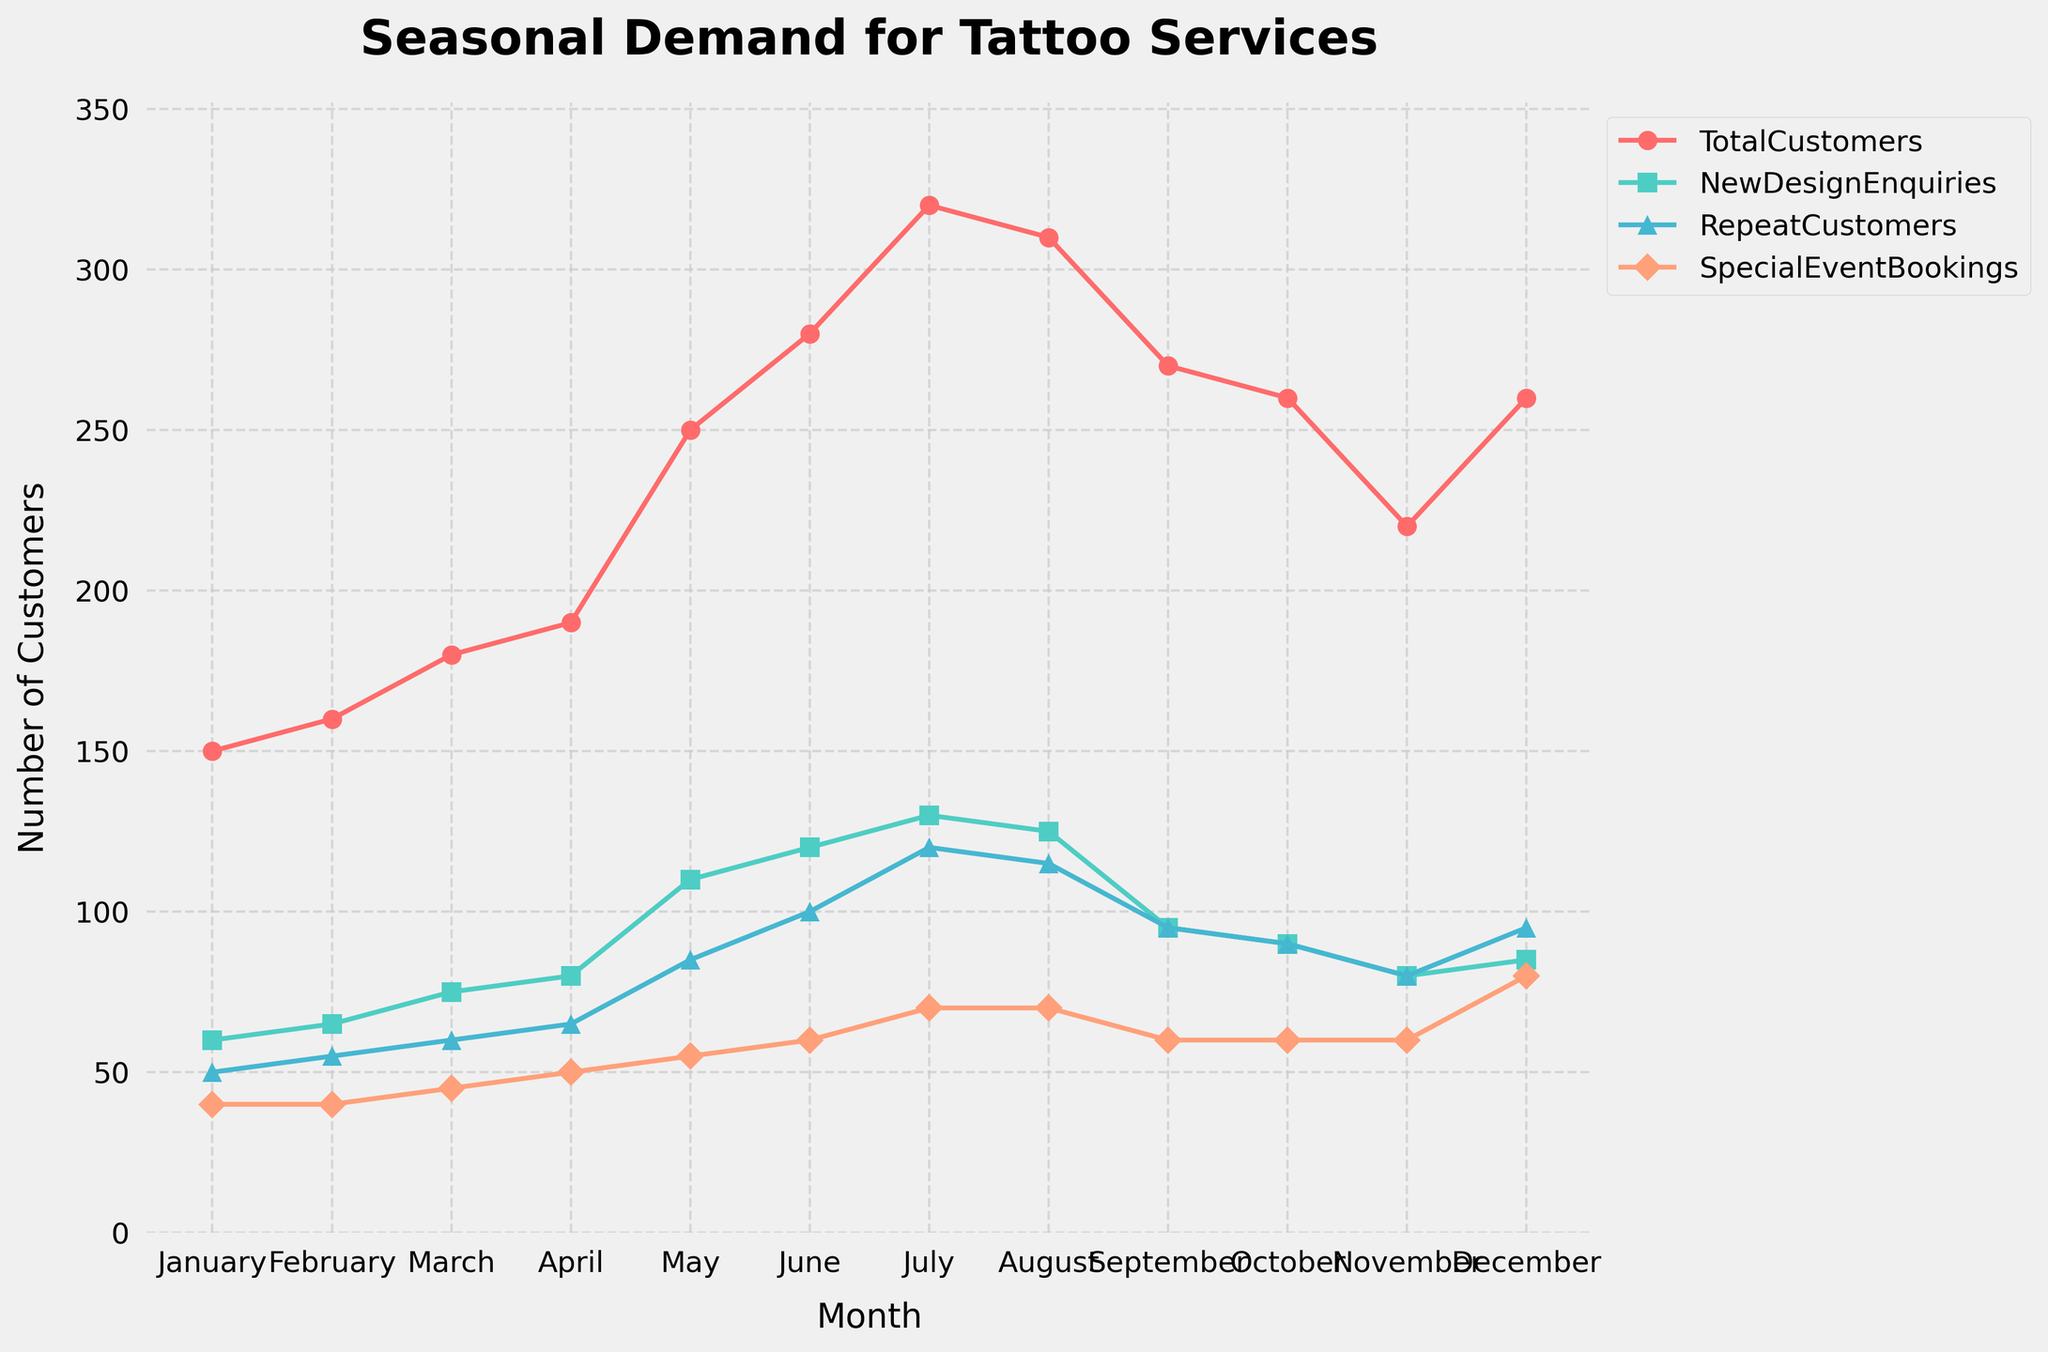What's the title of the chart? The title is displayed prominently at the top of the chart. It reads 'Seasonal Demand for Tattoo Services'.
Answer: Seasonal Demand for Tattoo Services Which metric has the highest value in July? By observing the chart, the line representing 'TotalCustomers' reaches the highest peak in July, above 300. This indicates 'TotalCustomers' has the highest value in July.
Answer: TotalCustomers Compare 'TotalCustomers' and 'SpecialEventBookings' in December. Which one is greater and by how much? In December, 'TotalCustomers' is around 260, while 'SpecialEventBookings' is around 80. The difference between them is 260 - 80.
Answer: TotalCustomers by 180 In which month did 'NewDesignEnquiries' reach its peak? By examining the chart, 'NewDesignEnquiries' is highest in July, indicated by the largest marker.
Answer: July Calculate the average number of 'RepeatCustomers' over the entire year. Adding all 'RepeatCustomers' values: 50+55+60+65+85+100+120+115+95+90+80+95 = 1020. Dividing by 12 months gives 1020 / 12.
Answer: 85 How does the number of 'TotalCustomers' change from May to June? The chart shows 'TotalCustomers' increasing from May (250) to June (280). The difference is 280 - 250.
Answer: Increases by 30 Which month shows the highest 'SpecialEventBookings', and what is the value? According to the chart, December shows the highest 'SpecialEventBookings' at a value of 80, represented by the highest peak for that metric.
Answer: December, 80 Is there a month where 'NewDesignEnquiries' and 'RepeatCustomers' have the same value? By comparing the lines for 'NewDesignEnquiries' and 'RepeatCustomers', they both have the value 95 in September.
Answer: September Which month sees the sharpest decline in 'TotalCustomers,' and what is the range of the decline? The chart shows that from August (310) to September (270), there is the sharpest decline in 'TotalCustomers.' The range is 310 - 270.
Answer: August to September, 40 What is the overall trend for 'TotalCustomers' throughout the year? Viewing the chart, 'TotalCustomers' trend upwards from January to July and then decreases towards November with a slight increase again in December.
Answer: Increasing then decreasing 